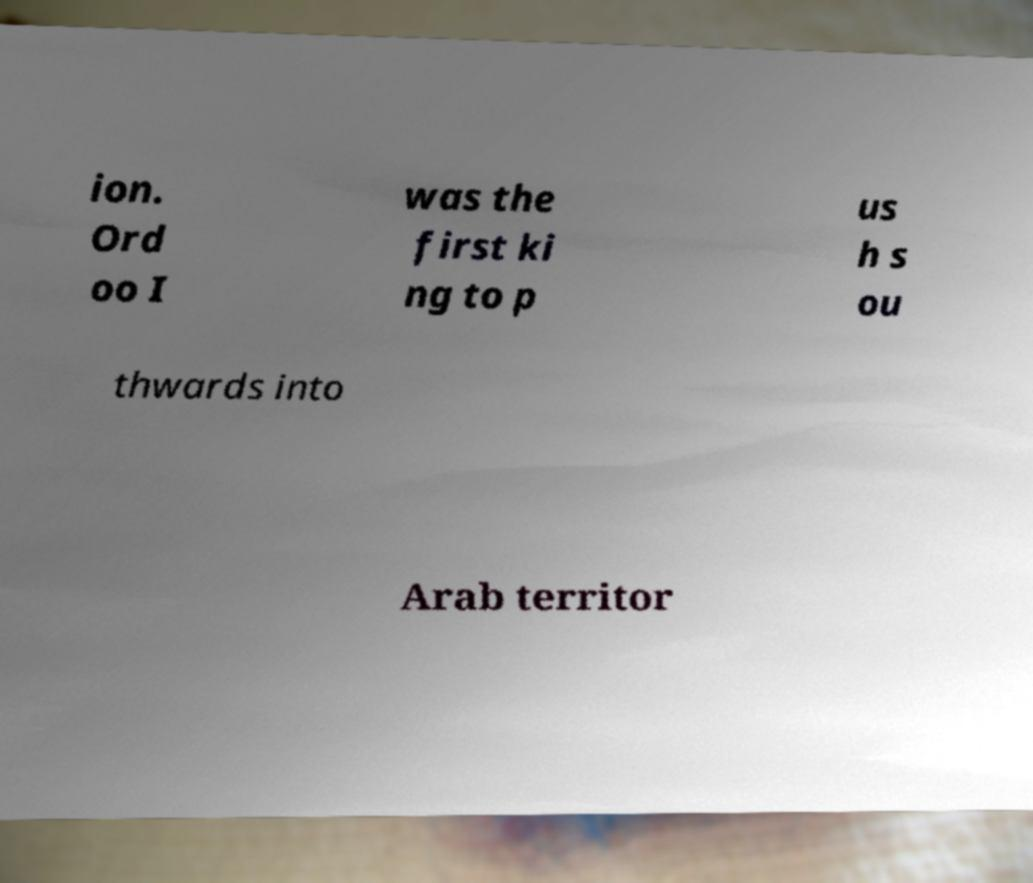Please identify and transcribe the text found in this image. ion. Ord oo I was the first ki ng to p us h s ou thwards into Arab territor 